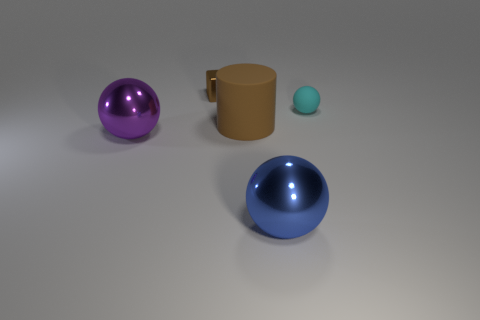Add 1 red shiny things. How many objects exist? 6 Subtract all large purple spheres. How many spheres are left? 2 Subtract all purple spheres. How many spheres are left? 2 Subtract 1 cubes. How many cubes are left? 0 Subtract all cylinders. How many objects are left? 4 Subtract all gray balls. Subtract all blue cylinders. How many balls are left? 3 Add 4 small brown objects. How many small brown objects are left? 5 Add 5 big metallic things. How many big metallic things exist? 7 Subtract 0 purple cylinders. How many objects are left? 5 Subtract all brown cubes. Subtract all blue metallic objects. How many objects are left? 3 